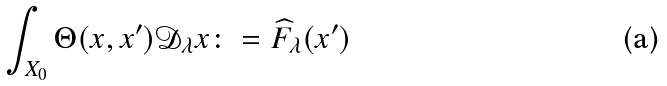Convert formula to latex. <formula><loc_0><loc_0><loc_500><loc_500>\int _ { X _ { 0 } } \Theta ( x , x ^ { \prime } ) \mathcal { D } _ { \lambda } x \colon = \widehat { F } _ { \lambda } ( x ^ { \prime } )</formula> 